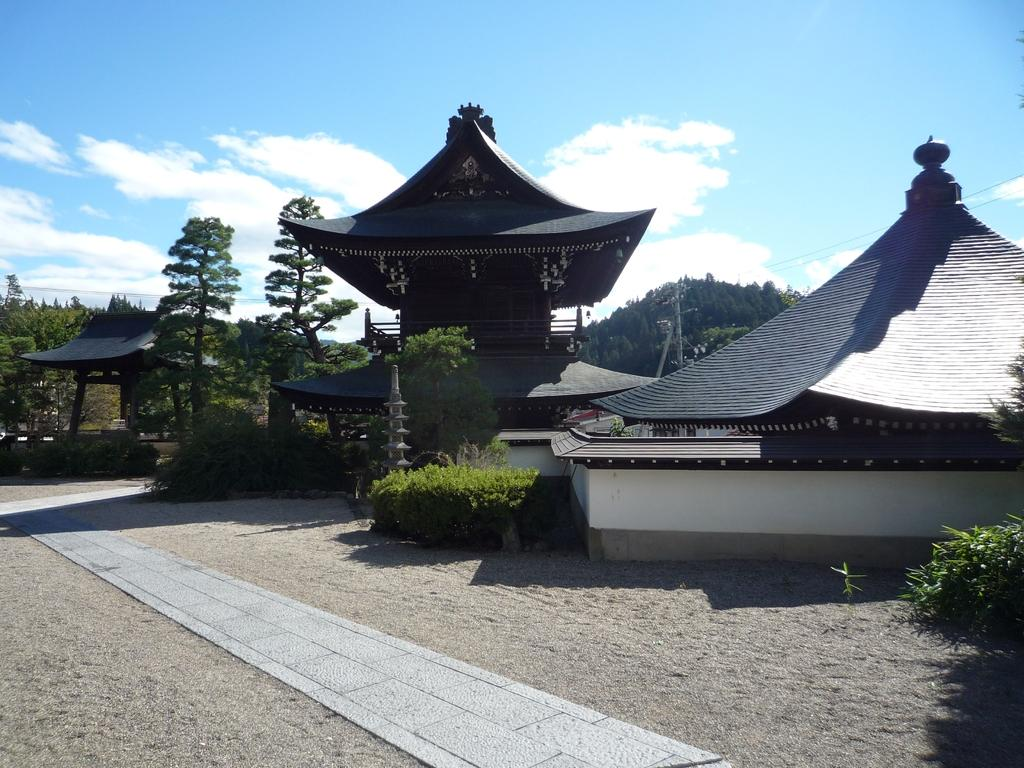What type of buildings are in the image? There are Buddha temples with roof tiles in the image. What can be seen in the background of the image? There are trees visible in the background of the image. What area is visible at the bottom front of the image? There is a walking area in the front bottom side of the image. What is visible at the top of the image? The sky is visible at the top of the image. What can be observed in the sky? Clouds are present in the sky. How is the rake being used in the image? There is no rake present in the image. What type of glue is being used to hold the clouds together in the image? There is no glue present in the image; the clouds are naturally occurring in the sky. 